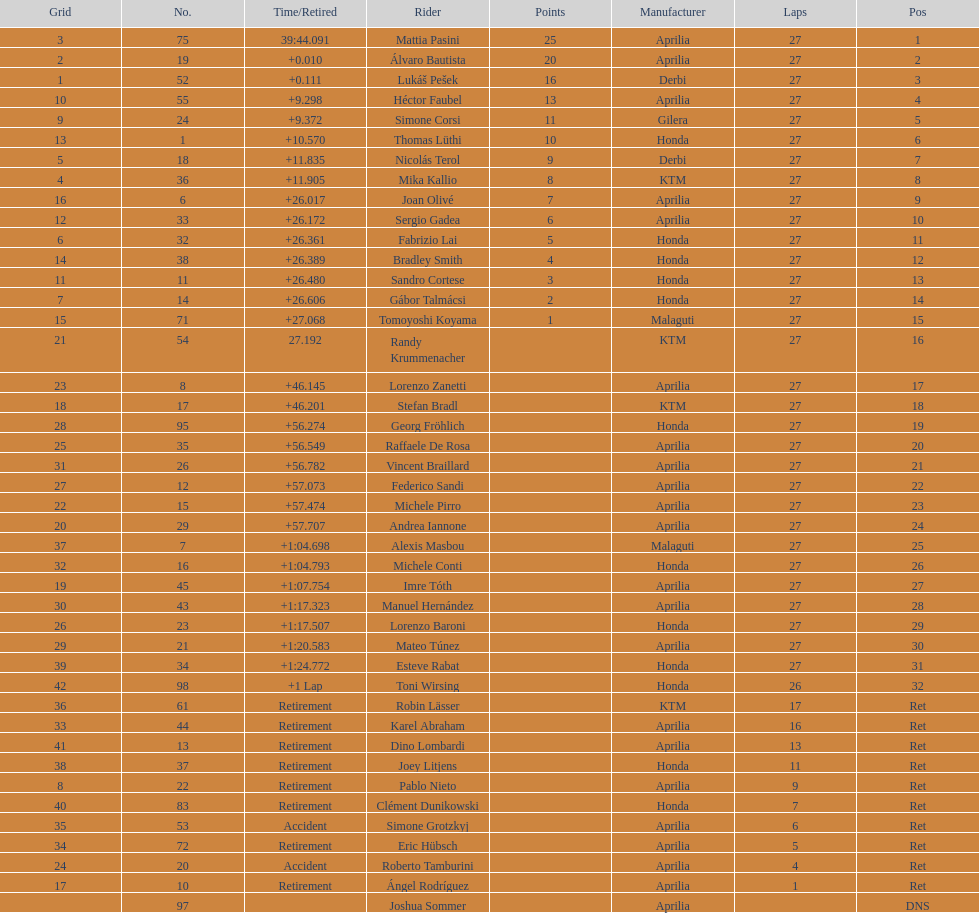Parse the full table. {'header': ['Grid', 'No.', 'Time/Retired', 'Rider', 'Points', 'Manufacturer', 'Laps', 'Pos'], 'rows': [['3', '75', '39:44.091', 'Mattia Pasini', '25', 'Aprilia', '27', '1'], ['2', '19', '+0.010', 'Álvaro Bautista', '20', 'Aprilia', '27', '2'], ['1', '52', '+0.111', 'Lukáš Pešek', '16', 'Derbi', '27', '3'], ['10', '55', '+9.298', 'Héctor Faubel', '13', 'Aprilia', '27', '4'], ['9', '24', '+9.372', 'Simone Corsi', '11', 'Gilera', '27', '5'], ['13', '1', '+10.570', 'Thomas Lüthi', '10', 'Honda', '27', '6'], ['5', '18', '+11.835', 'Nicolás Terol', '9', 'Derbi', '27', '7'], ['4', '36', '+11.905', 'Mika Kallio', '8', 'KTM', '27', '8'], ['16', '6', '+26.017', 'Joan Olivé', '7', 'Aprilia', '27', '9'], ['12', '33', '+26.172', 'Sergio Gadea', '6', 'Aprilia', '27', '10'], ['6', '32', '+26.361', 'Fabrizio Lai', '5', 'Honda', '27', '11'], ['14', '38', '+26.389', 'Bradley Smith', '4', 'Honda', '27', '12'], ['11', '11', '+26.480', 'Sandro Cortese', '3', 'Honda', '27', '13'], ['7', '14', '+26.606', 'Gábor Talmácsi', '2', 'Honda', '27', '14'], ['15', '71', '+27.068', 'Tomoyoshi Koyama', '1', 'Malaguti', '27', '15'], ['21', '54', '27.192', 'Randy Krummenacher', '', 'KTM', '27', '16'], ['23', '8', '+46.145', 'Lorenzo Zanetti', '', 'Aprilia', '27', '17'], ['18', '17', '+46.201', 'Stefan Bradl', '', 'KTM', '27', '18'], ['28', '95', '+56.274', 'Georg Fröhlich', '', 'Honda', '27', '19'], ['25', '35', '+56.549', 'Raffaele De Rosa', '', 'Aprilia', '27', '20'], ['31', '26', '+56.782', 'Vincent Braillard', '', 'Aprilia', '27', '21'], ['27', '12', '+57.073', 'Federico Sandi', '', 'Aprilia', '27', '22'], ['22', '15', '+57.474', 'Michele Pirro', '', 'Aprilia', '27', '23'], ['20', '29', '+57.707', 'Andrea Iannone', '', 'Aprilia', '27', '24'], ['37', '7', '+1:04.698', 'Alexis Masbou', '', 'Malaguti', '27', '25'], ['32', '16', '+1:04.793', 'Michele Conti', '', 'Honda', '27', '26'], ['19', '45', '+1:07.754', 'Imre Tóth', '', 'Aprilia', '27', '27'], ['30', '43', '+1:17.323', 'Manuel Hernández', '', 'Aprilia', '27', '28'], ['26', '23', '+1:17.507', 'Lorenzo Baroni', '', 'Honda', '27', '29'], ['29', '21', '+1:20.583', 'Mateo Túnez', '', 'Aprilia', '27', '30'], ['39', '34', '+1:24.772', 'Esteve Rabat', '', 'Honda', '27', '31'], ['42', '98', '+1 Lap', 'Toni Wirsing', '', 'Honda', '26', '32'], ['36', '61', 'Retirement', 'Robin Lässer', '', 'KTM', '17', 'Ret'], ['33', '44', 'Retirement', 'Karel Abraham', '', 'Aprilia', '16', 'Ret'], ['41', '13', 'Retirement', 'Dino Lombardi', '', 'Aprilia', '13', 'Ret'], ['38', '37', 'Retirement', 'Joey Litjens', '', 'Honda', '11', 'Ret'], ['8', '22', 'Retirement', 'Pablo Nieto', '', 'Aprilia', '9', 'Ret'], ['40', '83', 'Retirement', 'Clément Dunikowski', '', 'Honda', '7', 'Ret'], ['35', '53', 'Accident', 'Simone Grotzkyj', '', 'Aprilia', '6', 'Ret'], ['34', '72', 'Retirement', 'Eric Hübsch', '', 'Aprilia', '5', 'Ret'], ['24', '20', 'Accident', 'Roberto Tamburini', '', 'Aprilia', '4', 'Ret'], ['17', '10', 'Retirement', 'Ángel Rodríguez', '', 'Aprilia', '1', 'Ret'], ['', '97', '', 'Joshua Sommer', '', 'Aprilia', '', 'DNS']]} What was the total number of positions in the 125cc classification? 43. 